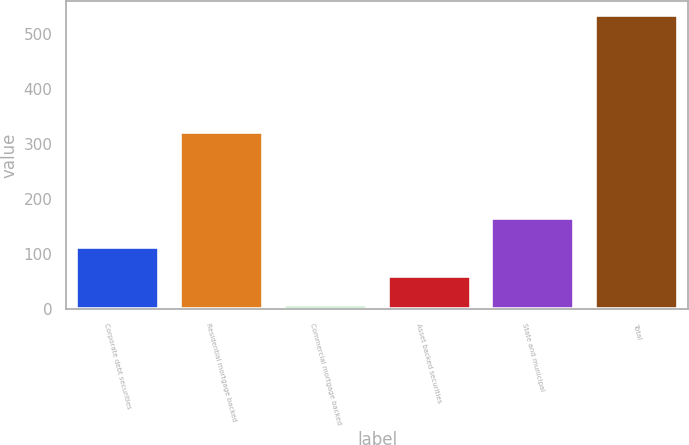Convert chart. <chart><loc_0><loc_0><loc_500><loc_500><bar_chart><fcel>Corporate debt securities<fcel>Residential mortgage backed<fcel>Commercial mortgage backed<fcel>Asset backed securities<fcel>State and municipal<fcel>Total<nl><fcel>113.2<fcel>323<fcel>8<fcel>60.6<fcel>165.8<fcel>534<nl></chart> 